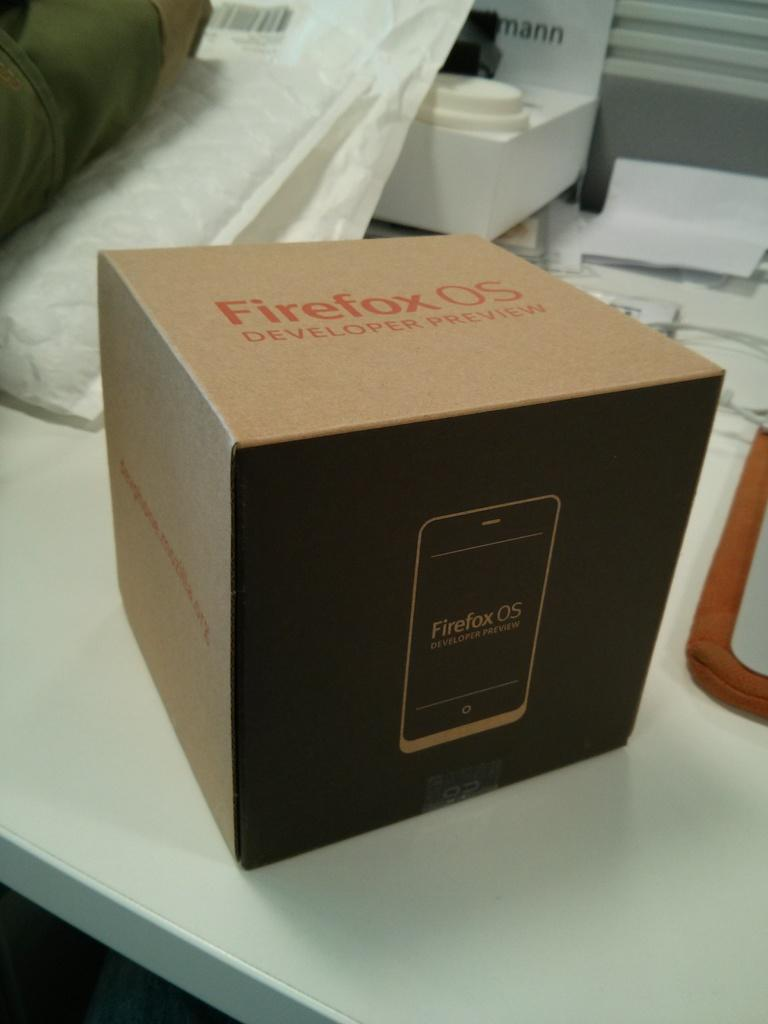<image>
Share a concise interpretation of the image provided. A Firefox OS box is on a white table. 